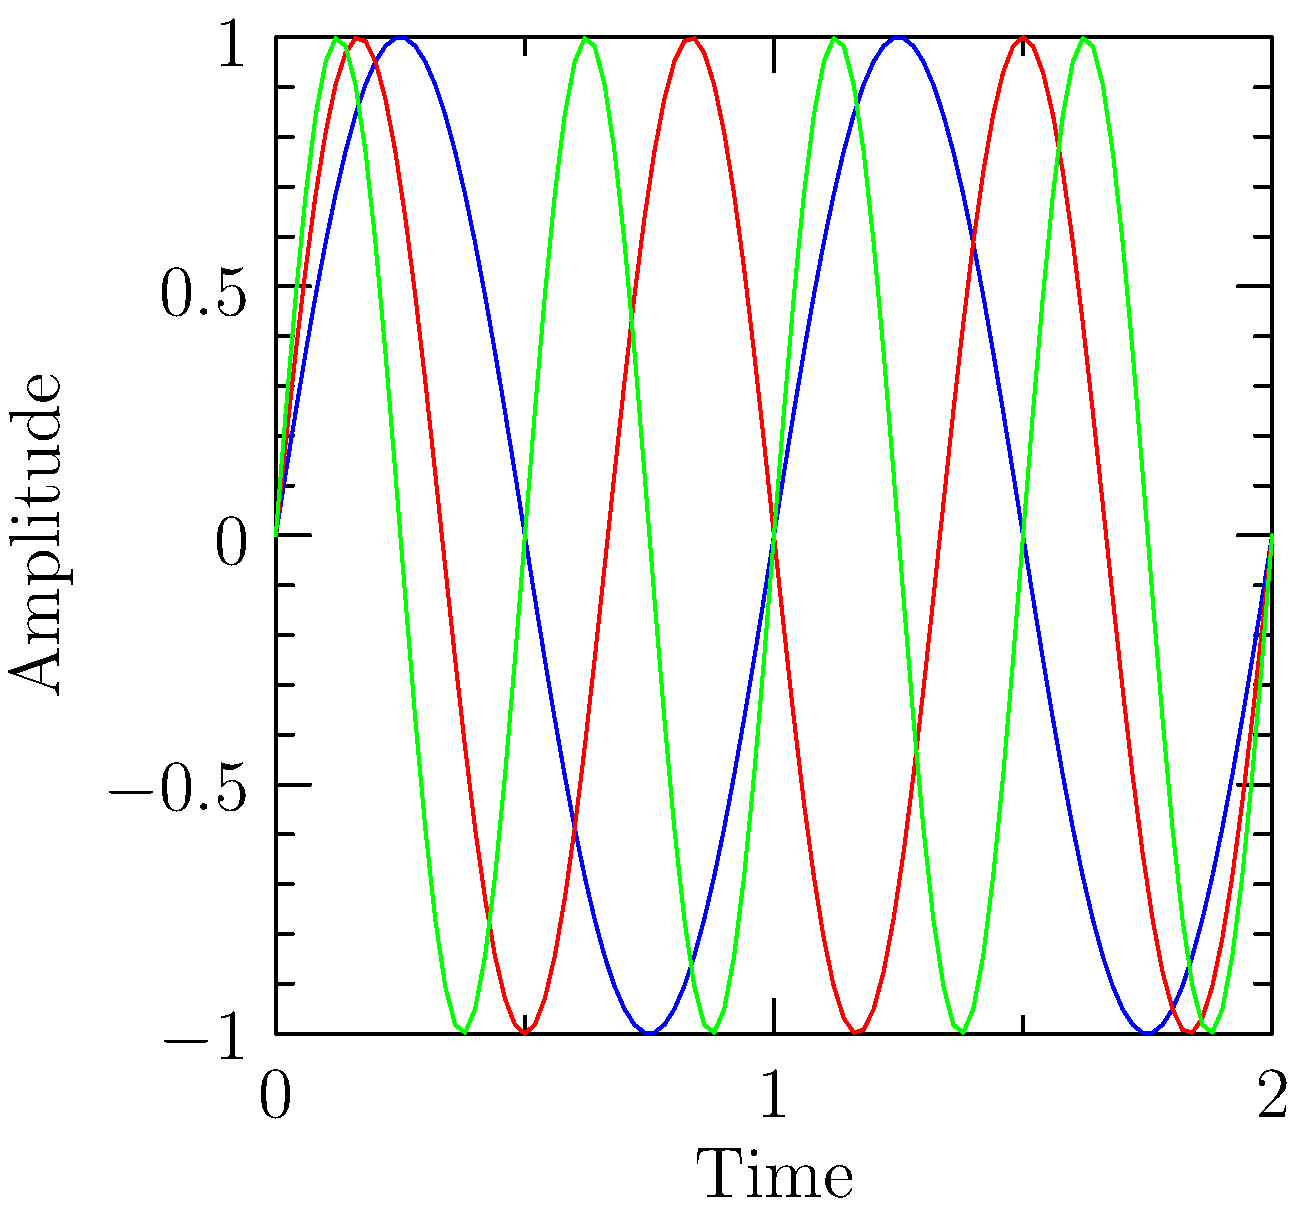Analyze the waveforms shown in the graph, which represent three Celtic musical scales: Ionian, Mixolydian, and Dorian. Which scale has the highest frequency, and how does this relate to the structure of Celtic music? To determine which scale has the highest frequency, we need to analyze the waveforms:

1. Observe the number of complete cycles within the given time frame:
   - Ionian (blue): 2 complete cycles
   - Mixolydian (red): 3 complete cycles
   - Dorian (green): 4 complete cycles

2. The scale with the most cycles has the highest frequency.

3. Dorian scale (green) has the most cycles, indicating the highest frequency.

4. In Celtic music, the Dorian mode is often used in traditional tunes, particularly in Irish and Scottish music. Its higher frequency gives it a brighter, more energetic sound compared to the Ionian (major) scale.

5. The Dorian mode is characterized by its raised 6th degree compared to the natural minor scale, which contributes to its distinctive sound in Celtic music.

6. The use of these different scales and modes in Celtic music allows for a rich variety of melodic expressions, with each scale providing a unique emotional and tonal quality to the music.

7. The higher frequency of the Dorian mode often corresponds to faster-paced, lively tunes in Celtic music, which are common in dance music and upbeat compositions.
Answer: Dorian scale; highest frequency reflects its bright, energetic character in Celtic music. 